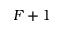<formula> <loc_0><loc_0><loc_500><loc_500>F + 1</formula> 